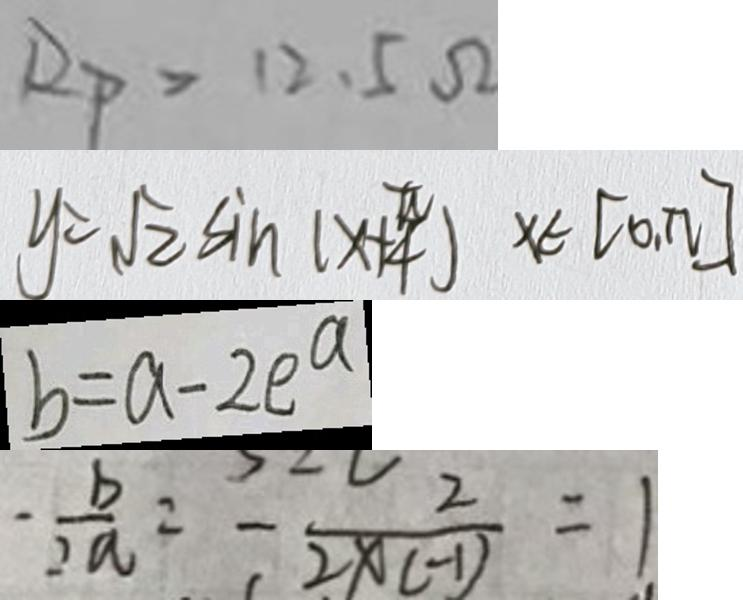Convert formula to latex. <formula><loc_0><loc_0><loc_500><loc_500>R _ { P } > 1 2 . 5 \Omega 
 y = \sqrt { 2 } \sin ( x + \frac { \pi } { 4 } ) x \in [ 0 , n ] 
 b = a - 2 e ^ { a } 
 - \frac { b } { 2 a } = - \frac { 2 } { 2 x ( - 1 ) } = 1</formula> 